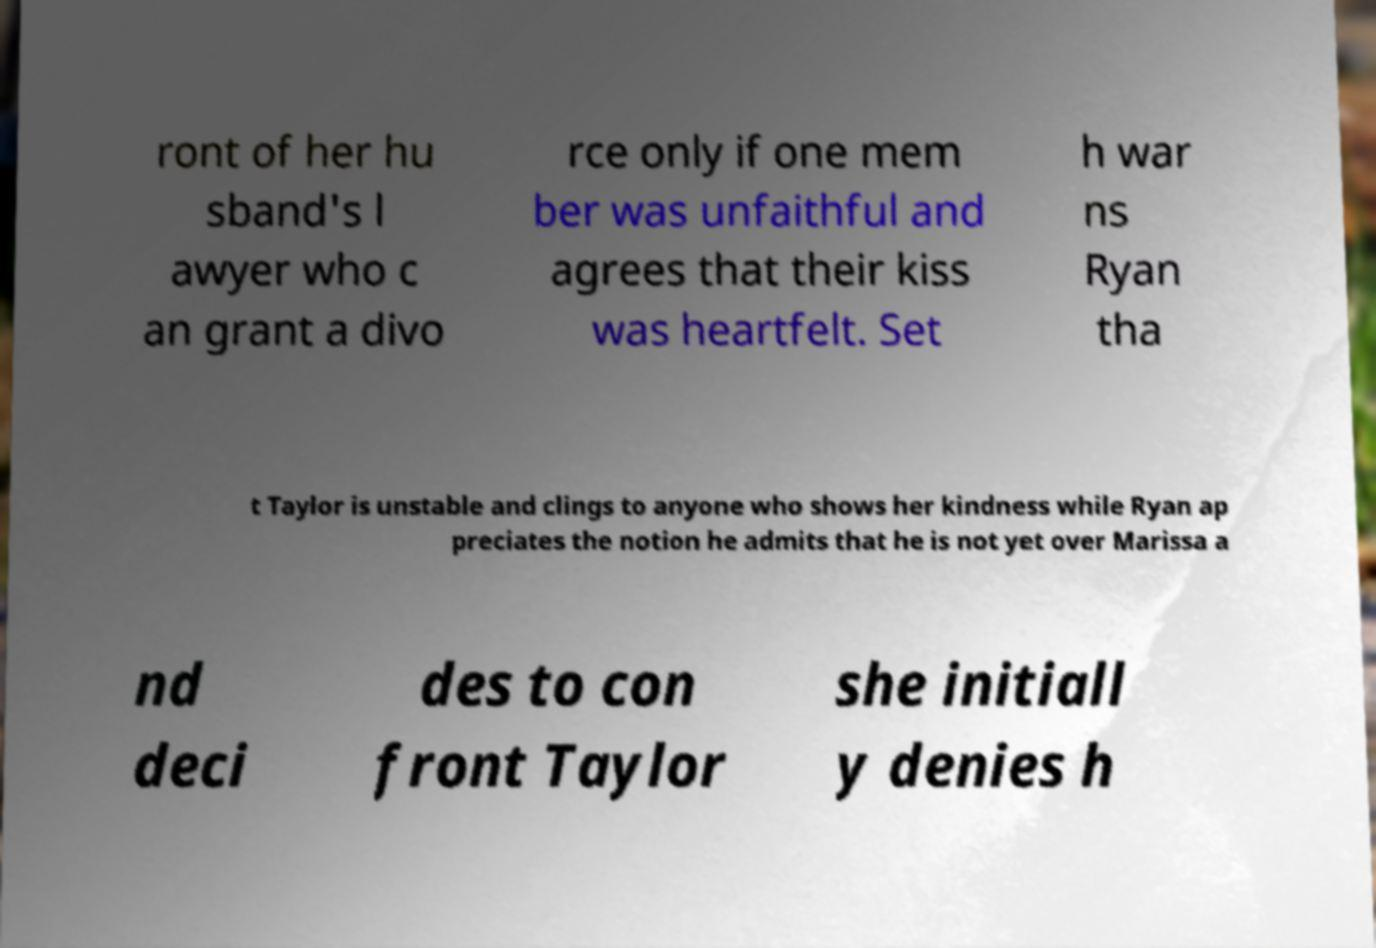For documentation purposes, I need the text within this image transcribed. Could you provide that? ront of her hu sband's l awyer who c an grant a divo rce only if one mem ber was unfaithful and agrees that their kiss was heartfelt. Set h war ns Ryan tha t Taylor is unstable and clings to anyone who shows her kindness while Ryan ap preciates the notion he admits that he is not yet over Marissa a nd deci des to con front Taylor she initiall y denies h 